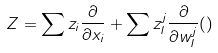<formula> <loc_0><loc_0><loc_500><loc_500>Z = \sum z _ { i } \frac { \partial } { \partial x _ { i } } + \sum z ^ { j } _ { I } \frac { \partial } { \partial w ^ { j } _ { I } } ( )</formula> 